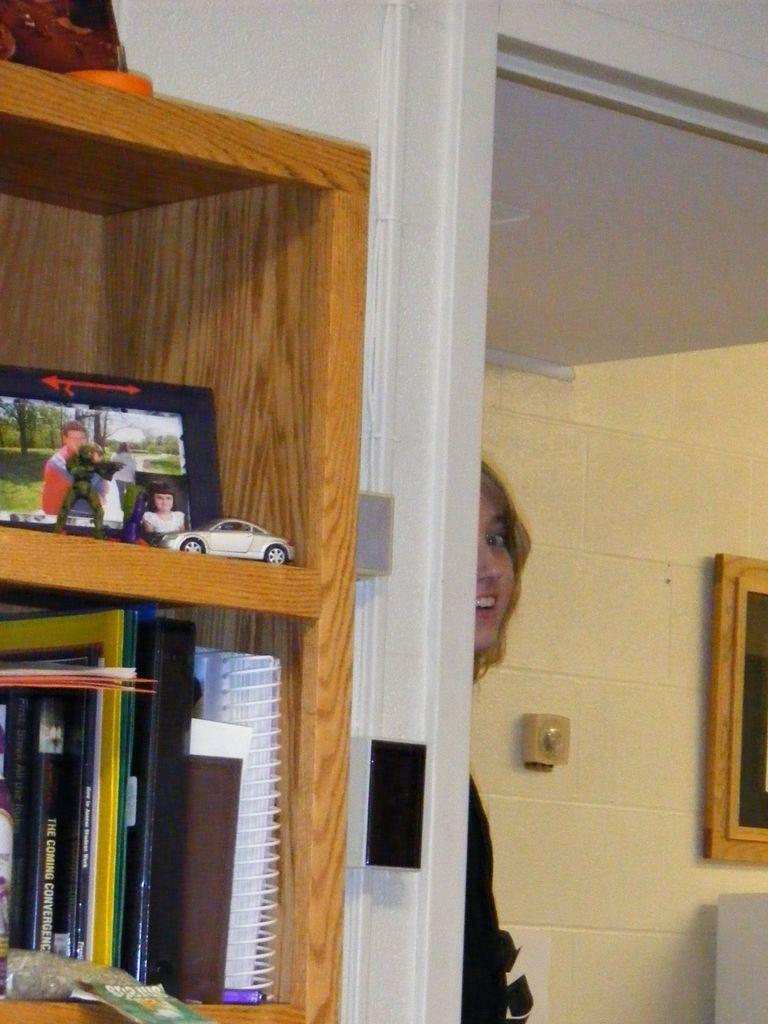Please provide a concise description of this image. In this image we can see the reflection of a woman standing on the floor in the mirror and some objects arranged in the cupboard. 